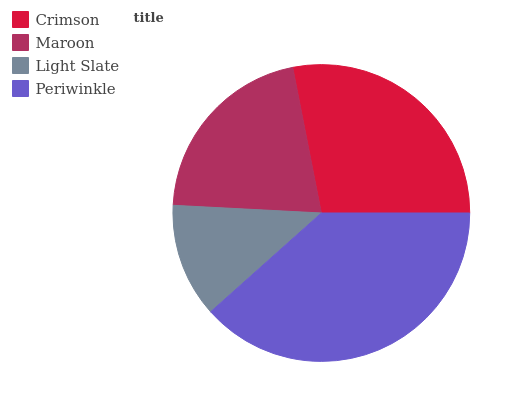Is Light Slate the minimum?
Answer yes or no. Yes. Is Periwinkle the maximum?
Answer yes or no. Yes. Is Maroon the minimum?
Answer yes or no. No. Is Maroon the maximum?
Answer yes or no. No. Is Crimson greater than Maroon?
Answer yes or no. Yes. Is Maroon less than Crimson?
Answer yes or no. Yes. Is Maroon greater than Crimson?
Answer yes or no. No. Is Crimson less than Maroon?
Answer yes or no. No. Is Crimson the high median?
Answer yes or no. Yes. Is Maroon the low median?
Answer yes or no. Yes. Is Light Slate the high median?
Answer yes or no. No. Is Light Slate the low median?
Answer yes or no. No. 